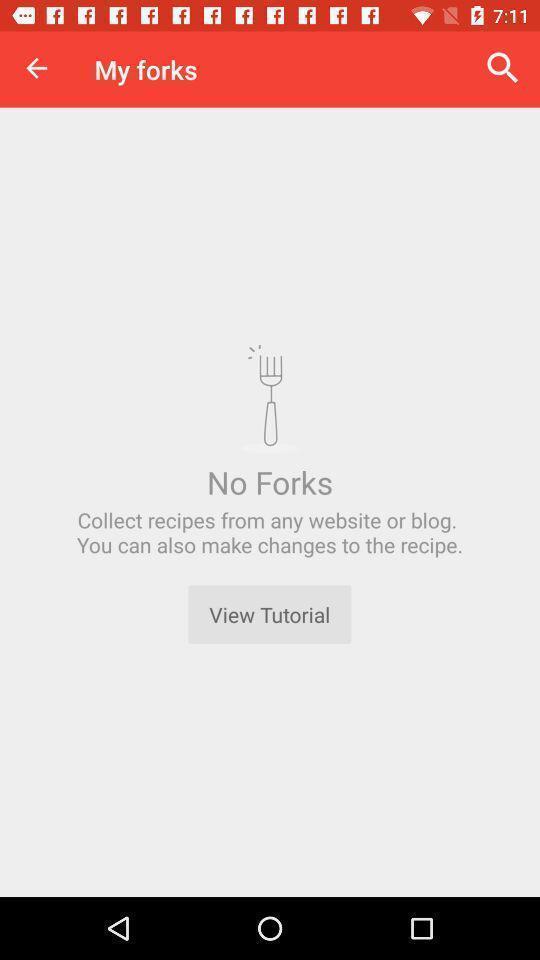Give me a narrative description of this picture. Screen shows no forks details in a food app. 